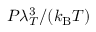<formula> <loc_0><loc_0><loc_500><loc_500>P \lambda _ { T } ^ { 3 } / ( k _ { B } T )</formula> 